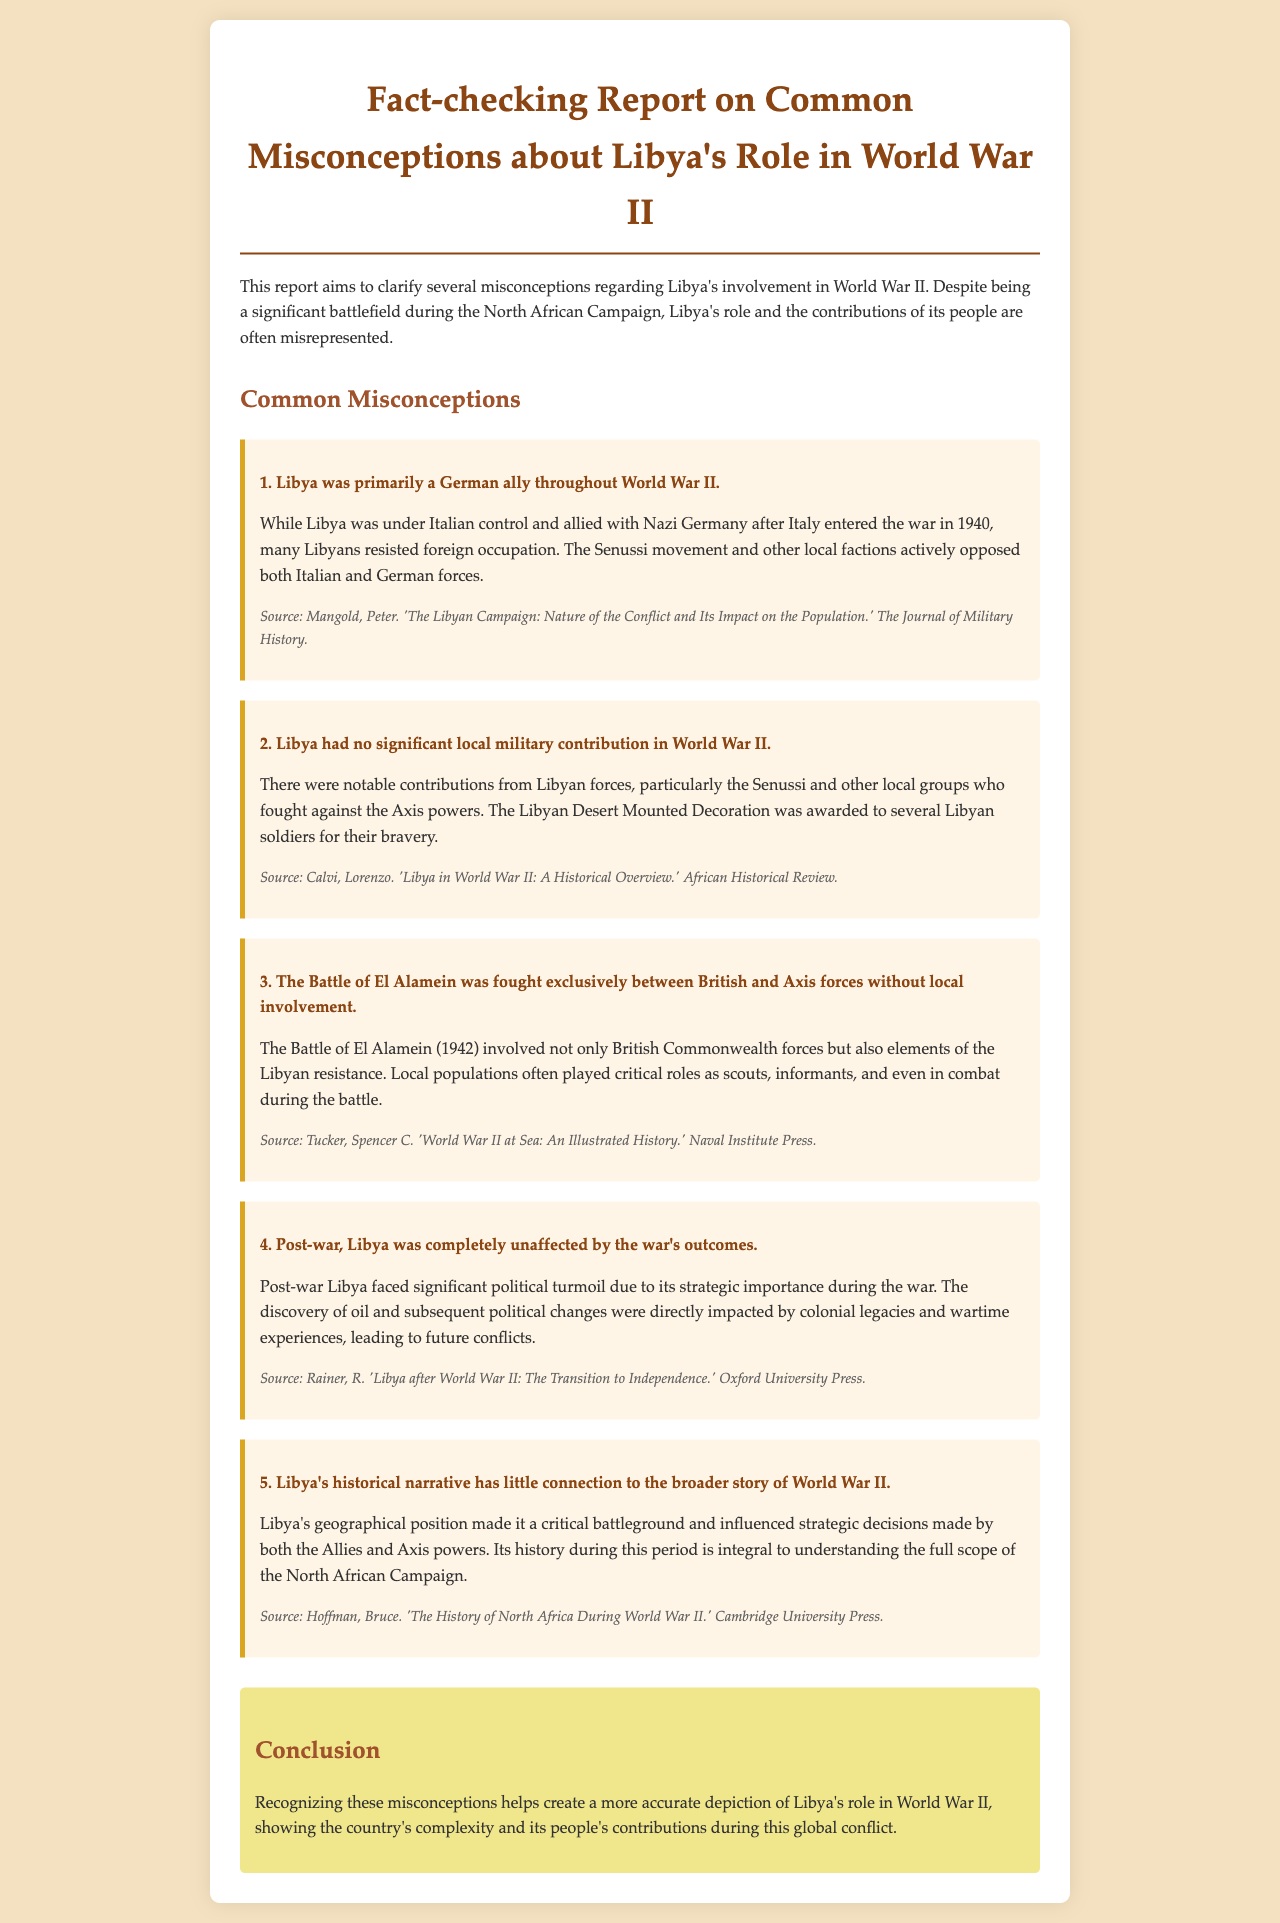What is the title of the report? The title of the report is found in the heading: "Fact-checking Report on Common Misconceptions about Libya's Role in World War II."
Answer: Fact-checking Report on Common Misconceptions about Libya's Role in World War II What is one misconception about Libya's role in World War II? The document lists several misconceptions; one example is "Libya was primarily a German ally throughout World War II."
Answer: Libya was primarily a German ally throughout World War II Who authored a source discussing the Libyan Campaign? The document mentions a specific author related to the Libyan Campaign source: Peter Mangold wrote about it.
Answer: Peter Mangold What was awarded to several Libyan soldiers for bravery? The report highlights a specific recognition: the Libyan Desert Mounted Decoration was awarded.
Answer: Libyan Desert Mounted Decoration Which battle involved local populations playing critical roles? The document specifies the battle where local populations were involved: the Battle of El Alamein.
Answer: Battle of El Alamein What was identified as a significant impact post-war Libya faced? The document indicates a significant political issue post-war: political turmoil due to its strategic importance.
Answer: Political turmoil What is the main conclusion of the report? The conclusion summarizes the purpose of the report: to create a more accurate depiction of Libya's role in World War II.
Answer: A more accurate depiction of Libya's role in World War II What did Libya's geographical position influence during World War II? The report indicates that Libya's position influenced strategic decisions made by the Allies and Axis powers.
Answer: Strategic decisions 